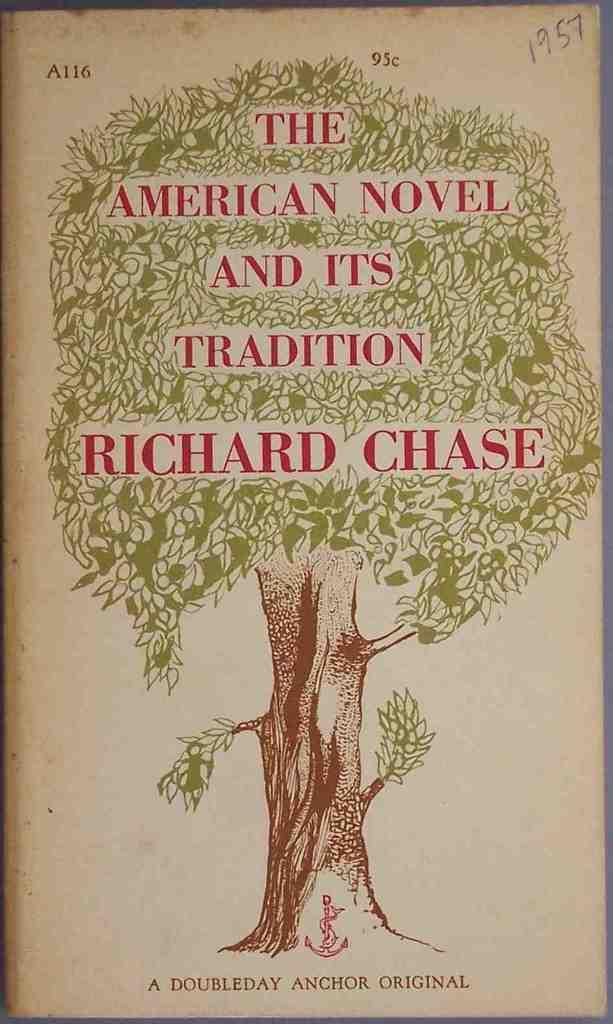What is the title of the book?
Your answer should be very brief. The american novel and its tradition. 